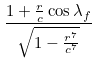<formula> <loc_0><loc_0><loc_500><loc_500>\frac { 1 + \frac { r } { c } \cos \lambda _ { f } } { \sqrt { 1 - \frac { r ^ { 7 } } { c ^ { 7 } } } }</formula> 